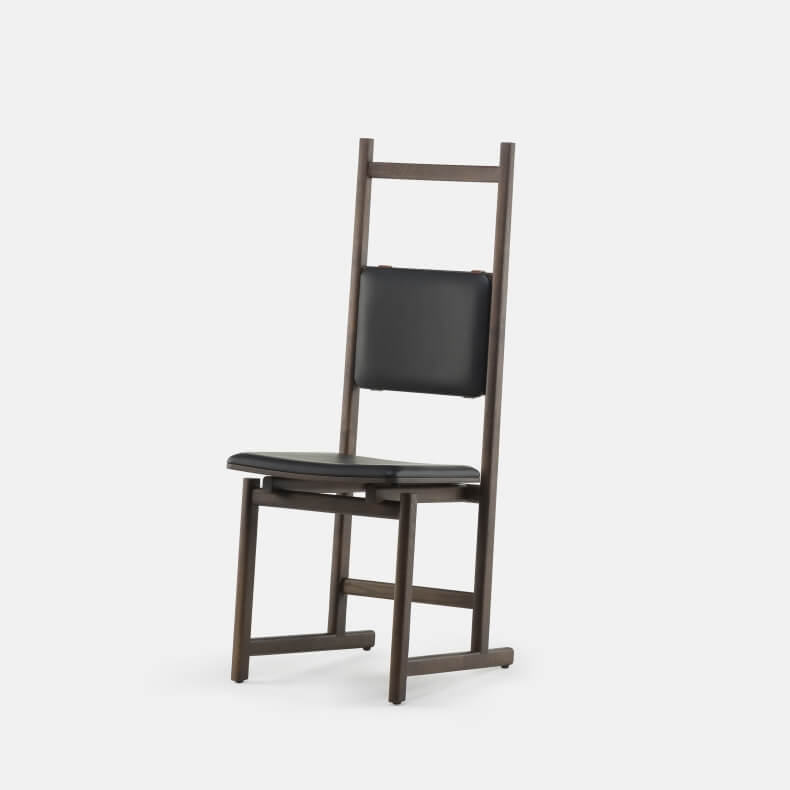Could this chair be paired with a specific table style for a cohesive look? If so, describe the ideal table. Absolutely! The chair’s minimalist aesthetic, characterized by its sleek lines and dark frame, would pair elegantly with a modern, minimalist table. An ideal table would feature a simple design, perhaps with a dark wood or metal finish that complements the chair’s frame. The table should have clean lines and a functional, uncluttered look. A glass tabletop could also enhance the modern vibe, providing a light and airy contrast to the darker, solid chair. Additionally, the table legs or base could mimic the chair’s geometric structure, creating a cohesive and stylish setting. Could this chair be part of a specific interior design theme? If so, which one and how would it integrate with other elements? Yes, this chair would be a perfect fit for a 'minimalist' interior design theme. In such a theme, the focus is on simplicity, functionality, and the use of high-quality materials. The chair’s clean lines, simple form, and dark color align perfectly with these principles. It would integrate seamlessly with other minimalist furniture pieces that emphasize straight lines and neutral colors. The overall look would be one of understated elegance and calm, with a focus on creating a clutter-free and serene environment. Other elements might include low-profile sofas, simple shelving units, and a few well-chosen decor items, such as monochrome art prints or a sleek pendant lamp. Imagine this chair in a whimsical fantasy world. What role would it play and why? In a whimsical fantasy world, this chair could be part of a magical council chamber where wise beings gather to make decisions. Its elegant design and sturdy construction suggest it’s a chair meant for someone with authority and wisdom. The chair might have hidden enchantments that provide comfort and support to those who sit in it, enhancing their ability to think clearly and make wise decisions. It could also change color or emit a soft glow when an important decision has been reached, symbolizing the power and significance of the moment. In this magical setting, the chair is not just a piece of furniture but a revered artifact with a history of being used by generations of council members. 